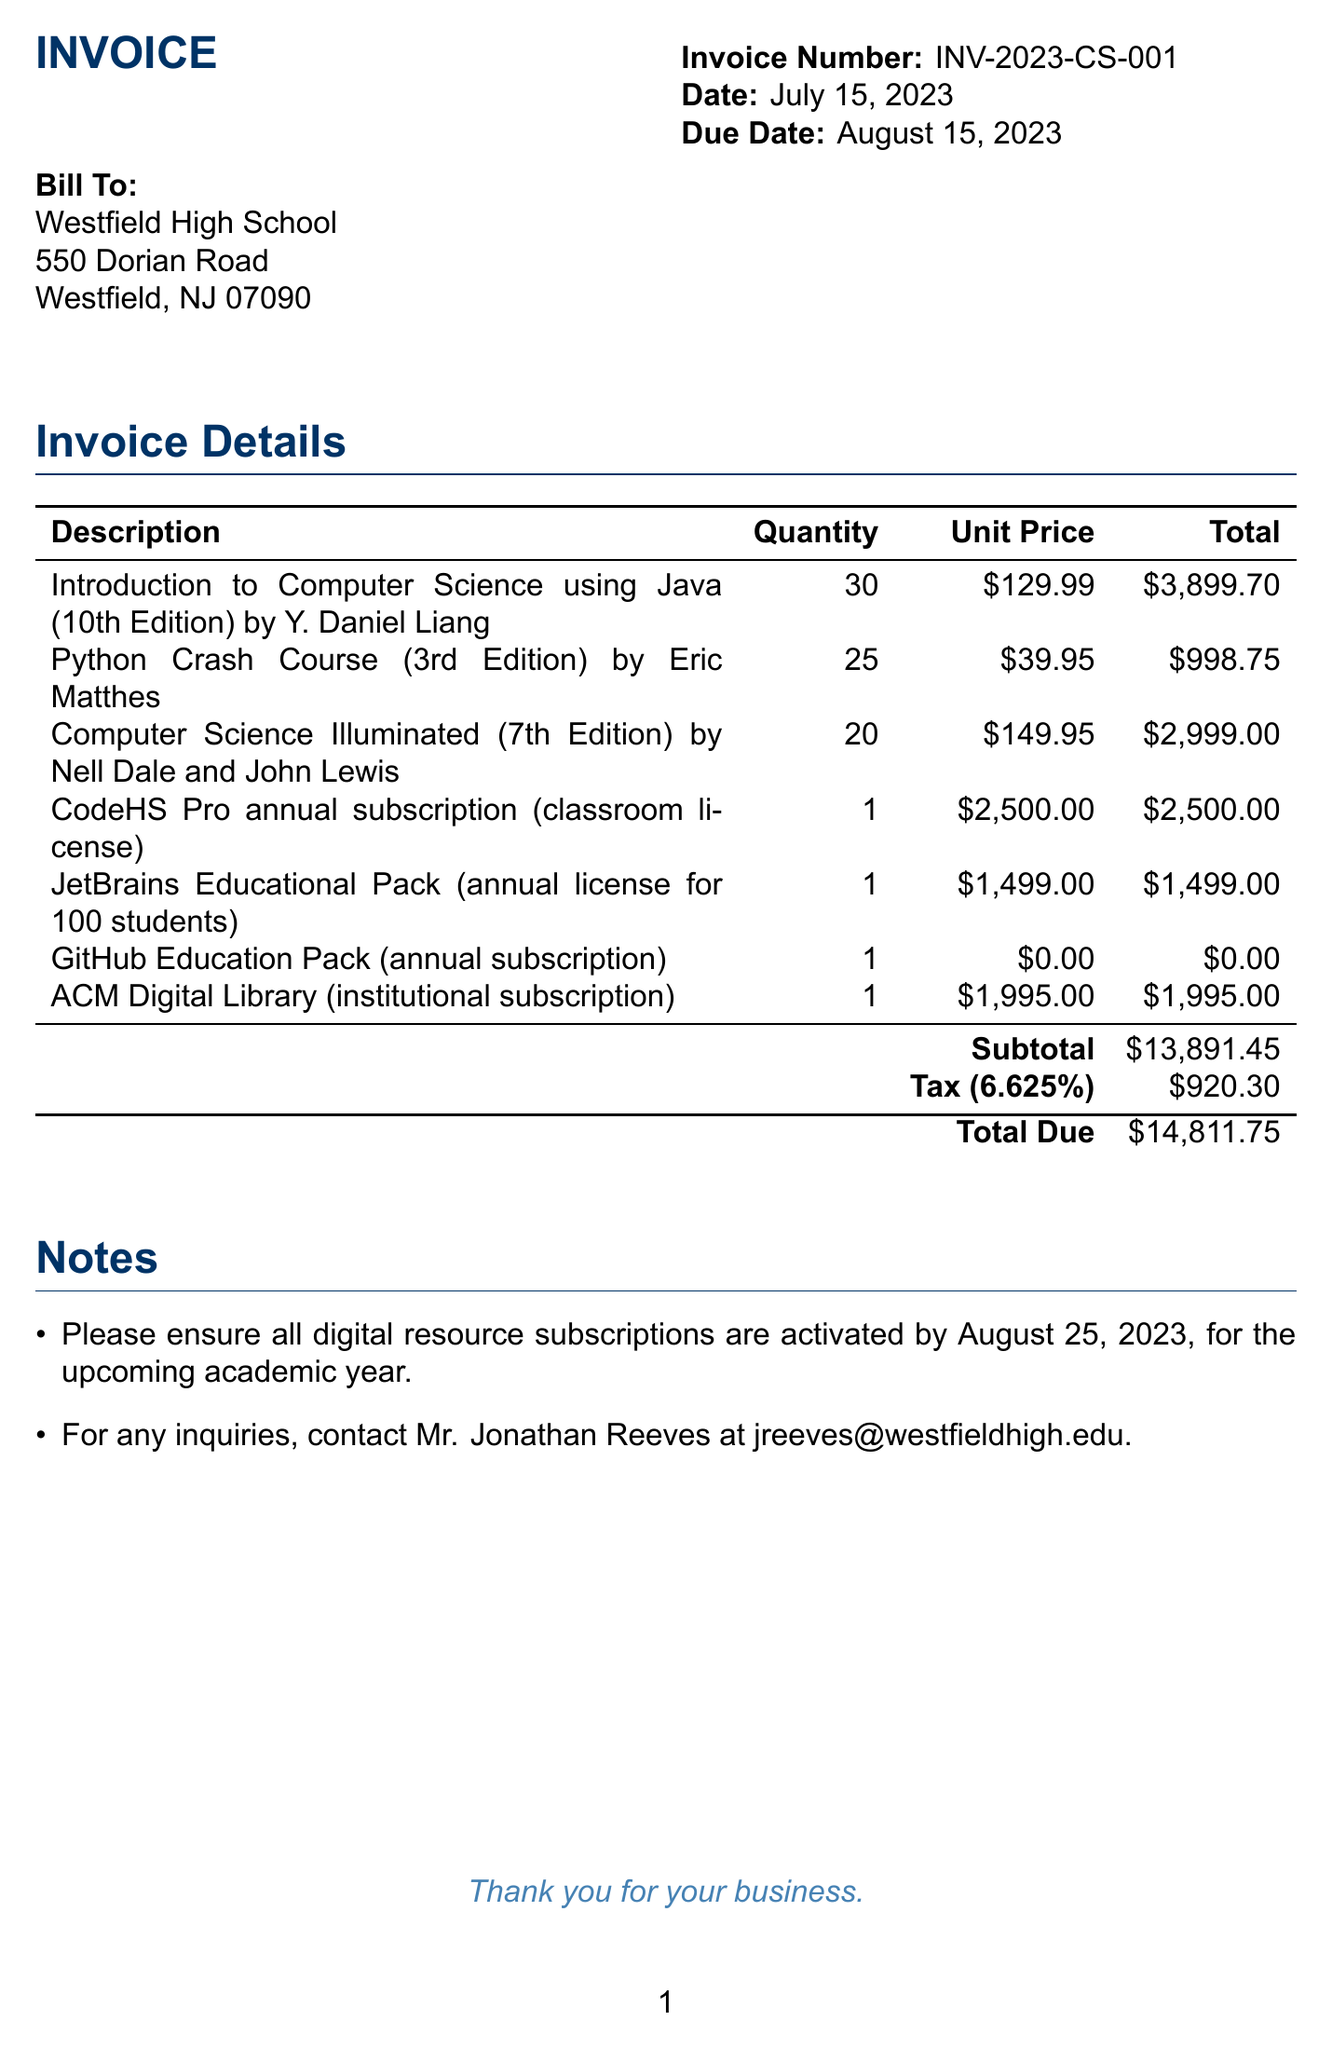What is the invoice number? The invoice number is a specific identifier for the transaction, stated at the top of the invoice.
Answer: INV-2023-CS-001 What is the date of the invoice? The date indicates when the invoice was issued, which is found on the document.
Answer: July 15, 2023 What is the total amount due? The total due is the final amount that needs to be paid, calculated at the end of the invoice.
Answer: $14,811.75 How many copies of 'Introduction to Computer Science using Java' were purchased? This information is retrieved from the itemized list of textbooks on the invoice.
Answer: 30 What is the tax rate applied to the invoice? The tax rate is indicated in the tax calculation section of the invoice.
Answer: 6.625% What is the subtotal before tax? The subtotal is the sum of all item totals before any tax is added, located in the invoice details.
Answer: $13,891.45 Who should be contacted for inquiries regarding the invoice? This detail is provided in the notes section of the invoice, indicating the contact person for questions.
Answer: Mr. Jonathan Reeves What is the due date for the payment? The due date indicates when the payment for the invoice is required, listed in the header.
Answer: August 15, 2023 What type of subscription is included in the invoice? The invoice includes several subscriptions, specifically listed under digital resources.
Answer: CodeHS Pro annual subscription 